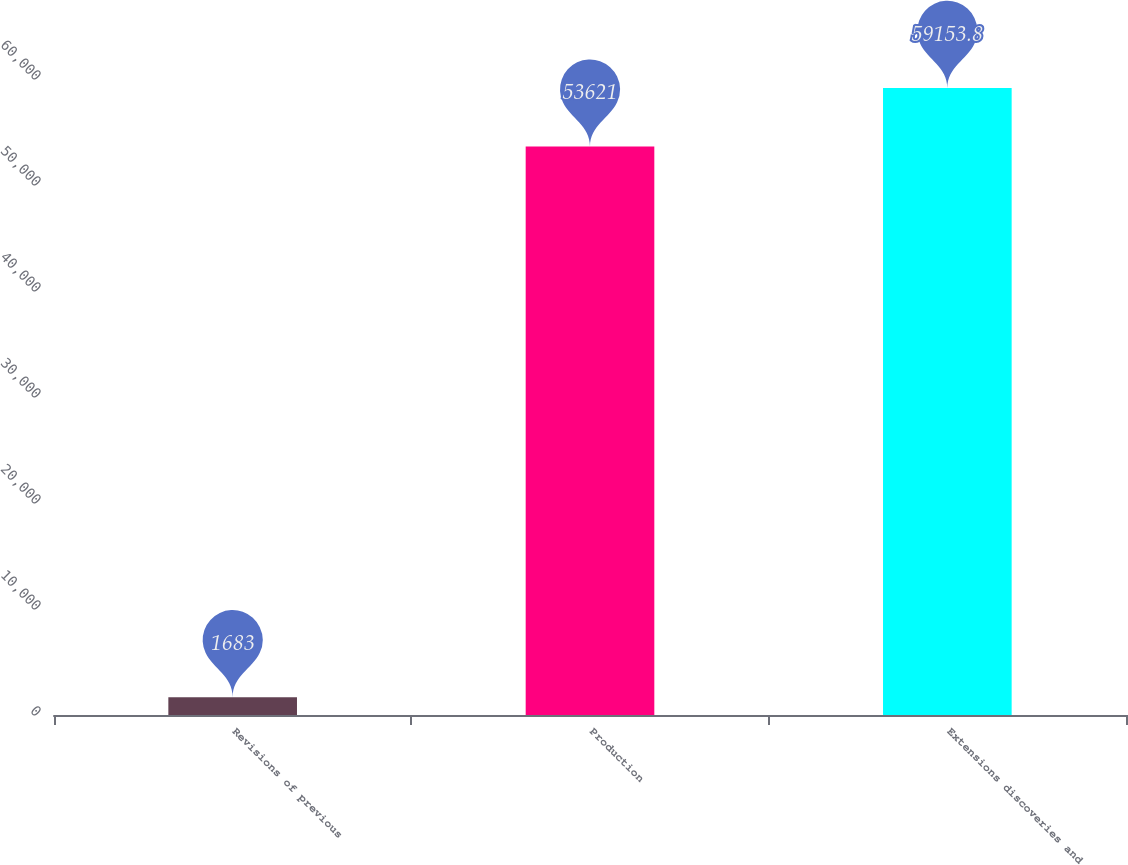Convert chart. <chart><loc_0><loc_0><loc_500><loc_500><bar_chart><fcel>Revisions of previous<fcel>Production<fcel>Extensions discoveries and<nl><fcel>1683<fcel>53621<fcel>59153.8<nl></chart> 